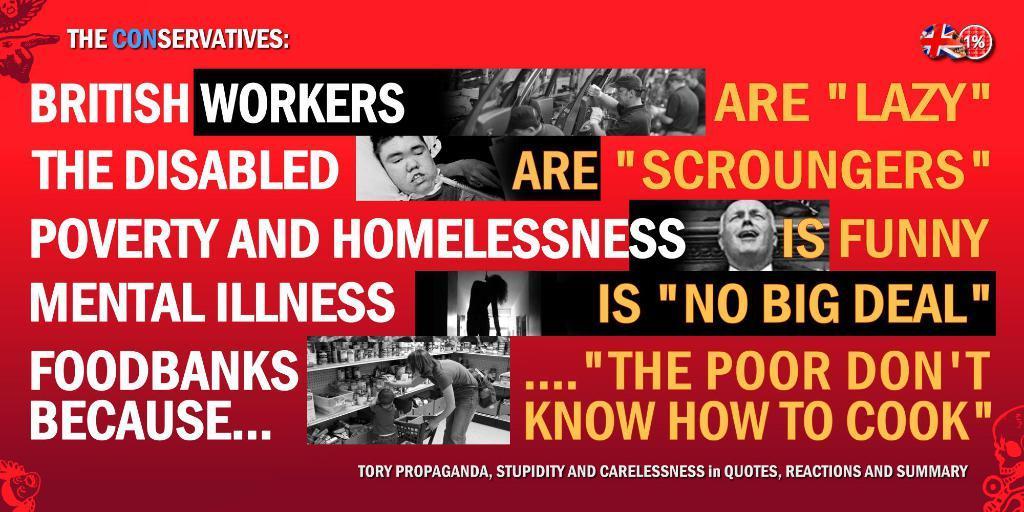Describe this image in one or two sentences. In this picture we can see a poster, in this poster we can see some text and five images, in this image we can see a person, a kid and shelves, there are some things present on these shelves, in this picture we can see a person is lying, in this picture there are four persons are standing, there is a logo at the right top of the picture. 